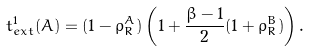<formula> <loc_0><loc_0><loc_500><loc_500>t _ { e x t } ^ { 1 } ( A ) = ( 1 - \rho _ { R } ^ { A } ) \left ( 1 + { \frac { \beta - 1 } { 2 } } ( 1 + \rho _ { R } ^ { B } ) \right ) .</formula> 